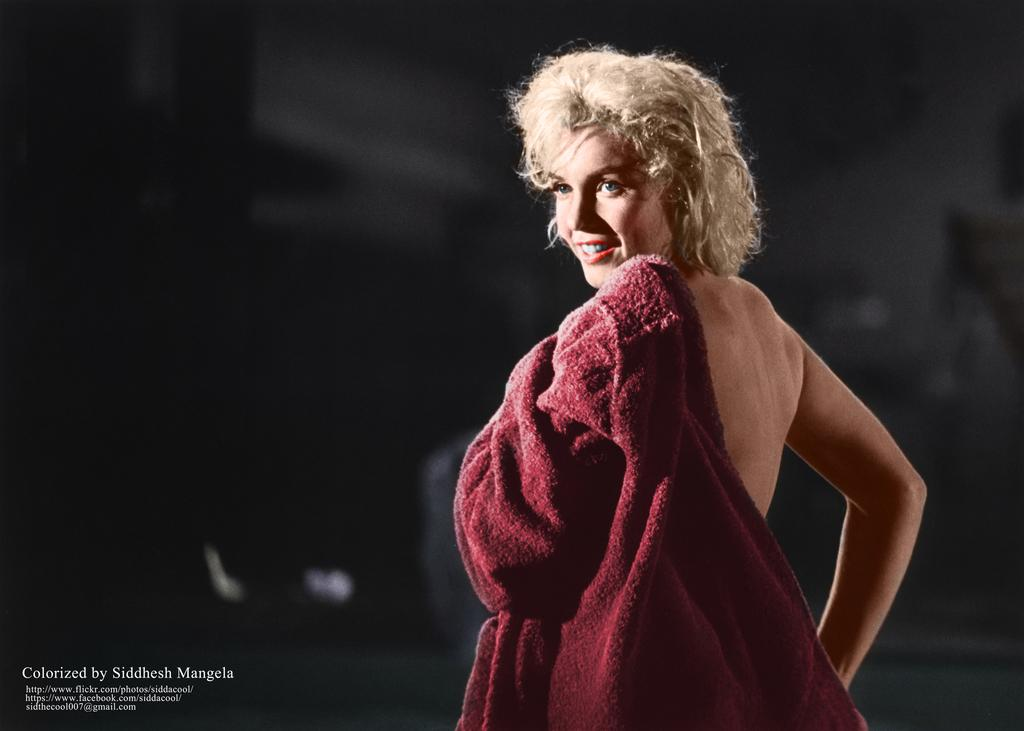Who is present in the image? There is a woman in the image. Where is the woman located in the image? The woman is standing on the right side. What is the woman holding in the image? The woman is holding a blanket. What can be seen at the bottom left corner of the image? There is text written at the bottom left corner of the image. What type of pest can be seen crawling on the woman's shoulder in the image? There is no pest visible on the woman's shoulder in the image. What branch is the woman sitting on in the image? The woman is standing, not sitting, and there is no branch present in the image. 